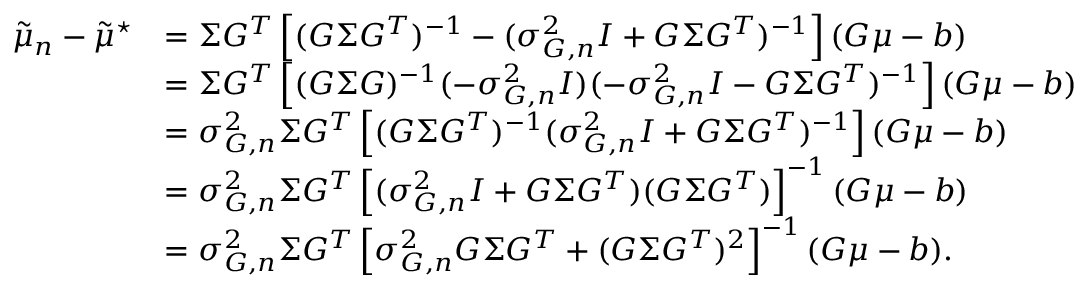Convert formula to latex. <formula><loc_0><loc_0><loc_500><loc_500>\begin{array} { r l } { \tilde { \mu } _ { n } - \tilde { \mu } ^ { ^ { * } } } & { = \Sigma G ^ { T } \left [ ( G \Sigma G ^ { T } ) ^ { - 1 } - ( \sigma _ { G , n } ^ { 2 } I + G \Sigma G ^ { T } ) ^ { - 1 } \right ] ( G \mu - b ) } \\ & { = \Sigma G ^ { T } \left [ ( G \Sigma G ) ^ { - 1 } ( - \sigma _ { G , n } ^ { 2 } I ) ( - \sigma _ { G , n } ^ { 2 } I - G \Sigma G ^ { T } ) ^ { - 1 } \right ] ( G \mu - b ) } \\ & { = \sigma _ { G , n } ^ { 2 } \Sigma G ^ { T } \left [ ( G \Sigma G ^ { T } ) ^ { - 1 } ( \sigma _ { G , n } ^ { 2 } I + G \Sigma G ^ { T } ) ^ { - 1 } \right ] ( G \mu - b ) } \\ & { = \sigma _ { G , n } ^ { 2 } \Sigma G ^ { T } \left [ ( \sigma _ { G , n } ^ { 2 } I + G \Sigma G ^ { T } ) ( G \Sigma G ^ { T } ) \right ] ^ { - 1 } ( G \mu - b ) } \\ & { = \sigma _ { G , n } ^ { 2 } \Sigma G ^ { T } \left [ \sigma _ { G , n } ^ { 2 } G \Sigma G ^ { T } + ( G \Sigma G ^ { T } ) ^ { 2 } \right ] ^ { - 1 } ( G \mu - b ) . } \end{array}</formula> 